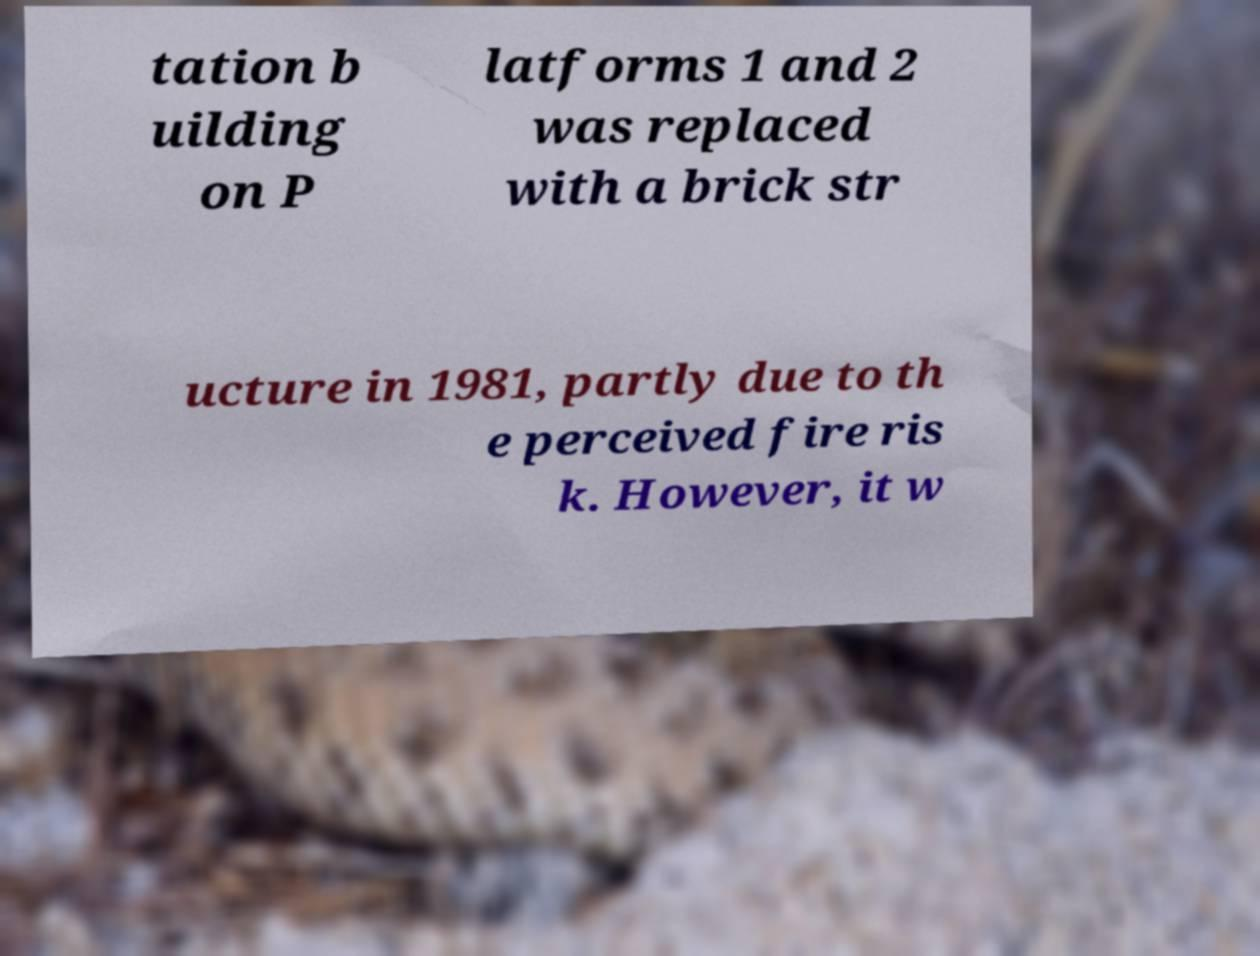Can you accurately transcribe the text from the provided image for me? tation b uilding on P latforms 1 and 2 was replaced with a brick str ucture in 1981, partly due to th e perceived fire ris k. However, it w 